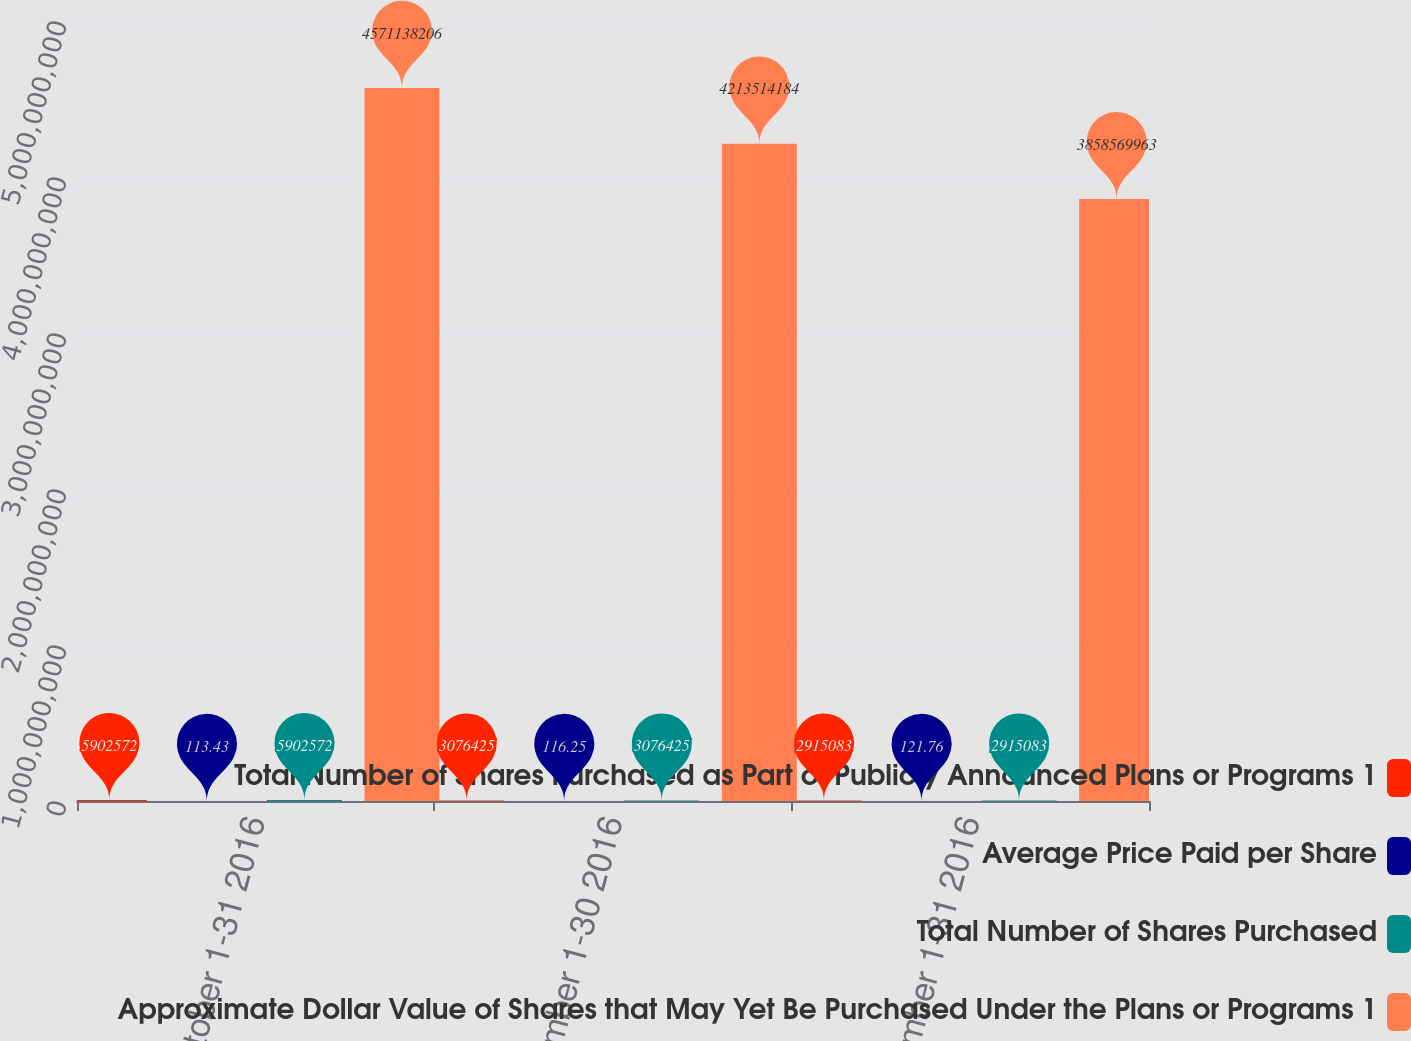<chart> <loc_0><loc_0><loc_500><loc_500><stacked_bar_chart><ecel><fcel>October 1-31 2016<fcel>November 1-30 2016<fcel>December 1-31 2016<nl><fcel>Total Number of Shares Purchased as Part of Publicly Announced Plans or Programs 1<fcel>5.90257e+06<fcel>3.07642e+06<fcel>2.91508e+06<nl><fcel>Average Price Paid per Share<fcel>113.43<fcel>116.25<fcel>121.76<nl><fcel>Total Number of Shares Purchased<fcel>5.90257e+06<fcel>3.07642e+06<fcel>2.91508e+06<nl><fcel>Approximate Dollar Value of Shares that May Yet Be Purchased Under the Plans or Programs 1<fcel>4.57114e+09<fcel>4.21351e+09<fcel>3.85857e+09<nl></chart> 